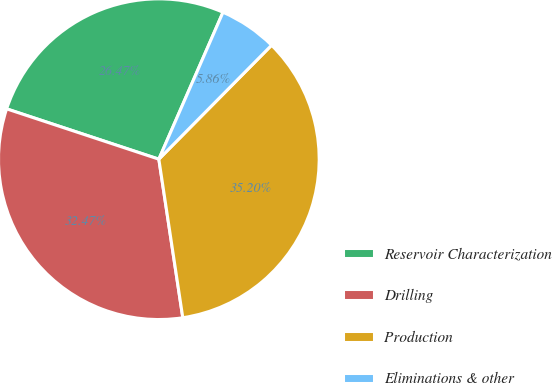<chart> <loc_0><loc_0><loc_500><loc_500><pie_chart><fcel>Reservoir Characterization<fcel>Drilling<fcel>Production<fcel>Eliminations & other<nl><fcel>26.47%<fcel>32.47%<fcel>35.2%<fcel>5.86%<nl></chart> 